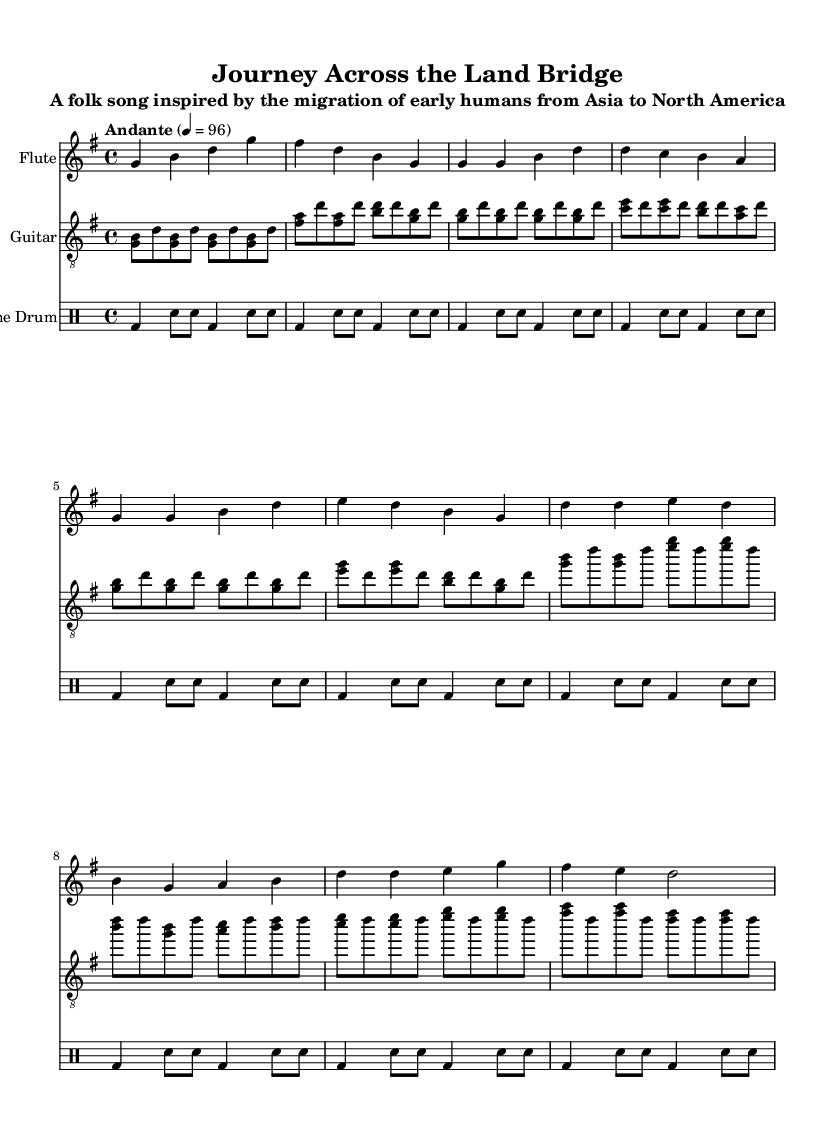What is the key signature of this music? The key signature is G major, which has one sharp, F#. This can be determined by looking at the key signature indicated at the beginning of the staff.
Answer: G major What is the time signature of this music? The time signature is 4/4, indicating four beats per measure. This is found at the start of the music after the key signature, defining the rhythmic structure.
Answer: 4/4 What is the tempo marking in this music? The tempo marking is "Andante," which indicates a moderate pace. This is mentioned at the beginning as part of the performance instructions.
Answer: Andante How many measures are there in the chorus section? There are four measures in the chorus section. By counting the measures indicated in the music and identifying the chorus section, we find there are four distinct measures.
Answer: 4 What instrument plays the melody in this piece? The flute plays the melody, as indicated by the instrument name above the flute staff and the distinct melodic lines written in that staff.
Answer: Flute How is the rhythm structured in the drum part during the intro? The rhythm in the drum part during the intro consists of a bass drum followed by snare hits, creating a pattern of bass and snare on alternating beats. This structural analysis of the first few measures reveals the specific rhythmic setup.
Answer: Bass and snare What migration story does this song represent? The song represents the migration of early humans from Asia to North America. This is indicated in the title and subtitle of the piece, which directly relates to themes of human migration.
Answer: Migration from Asia to North America 